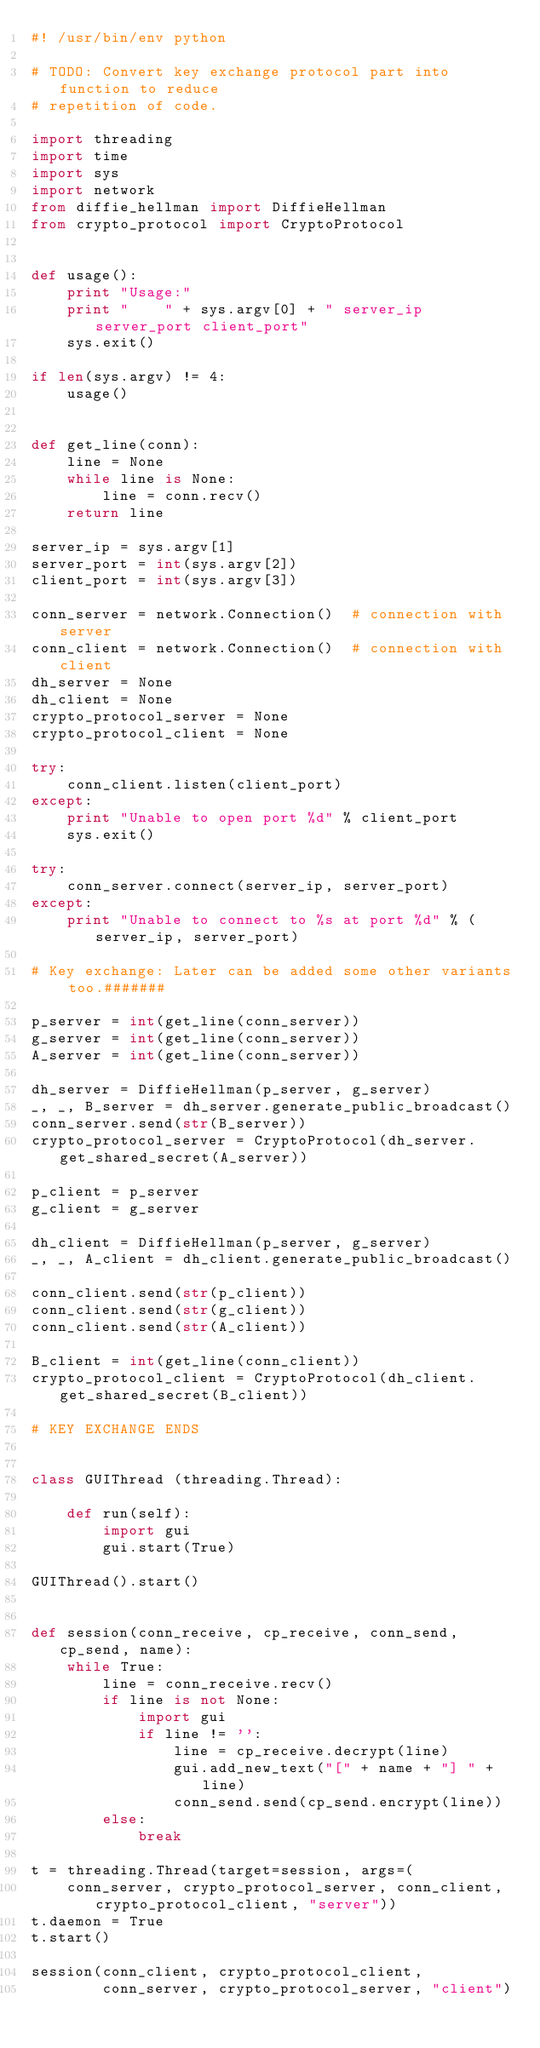<code> <loc_0><loc_0><loc_500><loc_500><_Python_>#! /usr/bin/env python

# TODO: Convert key exchange protocol part into function to reduce
# repetition of code.

import threading
import time
import sys
import network
from diffie_hellman import DiffieHellman
from crypto_protocol import CryptoProtocol


def usage():
    print "Usage:"
    print "    " + sys.argv[0] + " server_ip server_port client_port"
    sys.exit()

if len(sys.argv) != 4:
    usage()


def get_line(conn):
    line = None
    while line is None:
        line = conn.recv()
    return line

server_ip = sys.argv[1]
server_port = int(sys.argv[2])
client_port = int(sys.argv[3])

conn_server = network.Connection()  # connection with server
conn_client = network.Connection()  # connection with client
dh_server = None
dh_client = None
crypto_protocol_server = None
crypto_protocol_client = None

try:
    conn_client.listen(client_port)
except:
    print "Unable to open port %d" % client_port
    sys.exit()

try:
    conn_server.connect(server_ip, server_port)
except:
    print "Unable to connect to %s at port %d" % (server_ip, server_port)

# Key exchange: Later can be added some other variants too.#######

p_server = int(get_line(conn_server))
g_server = int(get_line(conn_server))
A_server = int(get_line(conn_server))

dh_server = DiffieHellman(p_server, g_server)
_, _, B_server = dh_server.generate_public_broadcast()
conn_server.send(str(B_server))
crypto_protocol_server = CryptoProtocol(dh_server.get_shared_secret(A_server))

p_client = p_server
g_client = g_server

dh_client = DiffieHellman(p_server, g_server)
_, _, A_client = dh_client.generate_public_broadcast()

conn_client.send(str(p_client))
conn_client.send(str(g_client))
conn_client.send(str(A_client))

B_client = int(get_line(conn_client))
crypto_protocol_client = CryptoProtocol(dh_client.get_shared_secret(B_client))

# KEY EXCHANGE ENDS


class GUIThread (threading.Thread):

    def run(self):
        import gui
        gui.start(True)

GUIThread().start()


def session(conn_receive, cp_receive, conn_send, cp_send, name):
    while True:
        line = conn_receive.recv()
        if line is not None:
            import gui
            if line != '':
                line = cp_receive.decrypt(line)
                gui.add_new_text("[" + name + "] " + line)
                conn_send.send(cp_send.encrypt(line))
        else:
            break

t = threading.Thread(target=session, args=(
    conn_server, crypto_protocol_server, conn_client, crypto_protocol_client, "server"))
t.daemon = True
t.start()

session(conn_client, crypto_protocol_client,
        conn_server, crypto_protocol_server, "client")
</code> 